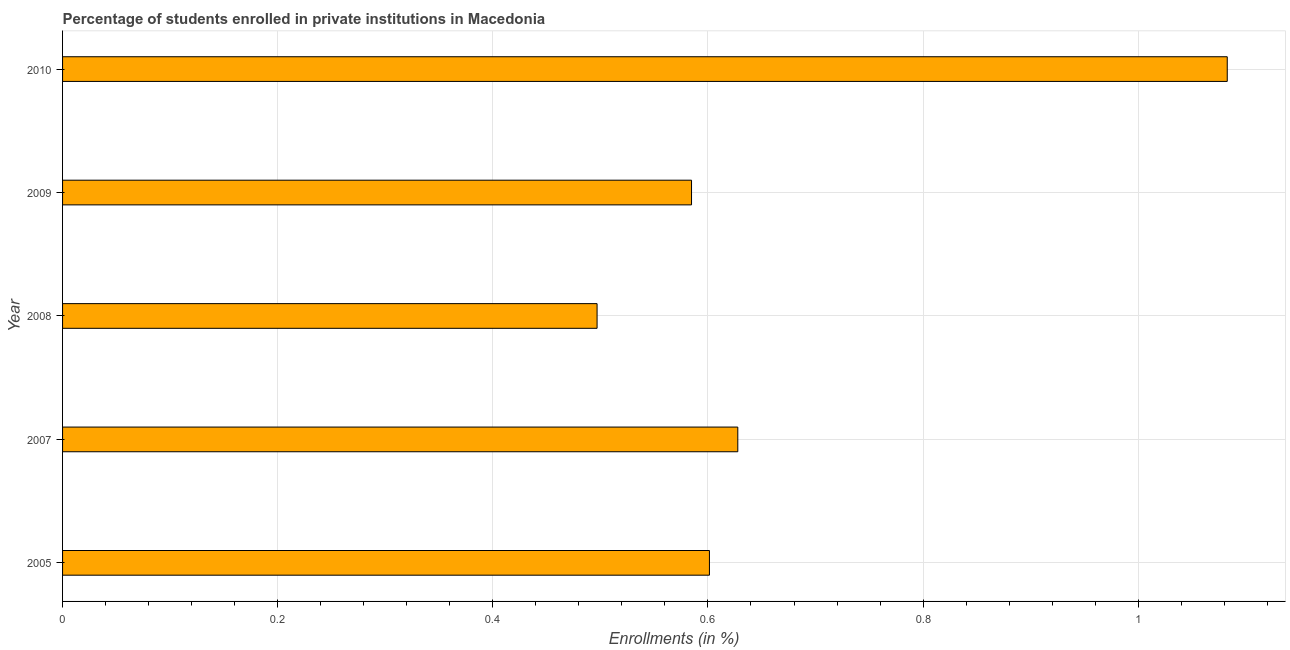Does the graph contain grids?
Your response must be concise. Yes. What is the title of the graph?
Offer a very short reply. Percentage of students enrolled in private institutions in Macedonia. What is the label or title of the X-axis?
Your response must be concise. Enrollments (in %). What is the enrollments in private institutions in 2007?
Give a very brief answer. 0.63. Across all years, what is the maximum enrollments in private institutions?
Keep it short and to the point. 1.08. Across all years, what is the minimum enrollments in private institutions?
Provide a succinct answer. 0.5. In which year was the enrollments in private institutions minimum?
Provide a succinct answer. 2008. What is the sum of the enrollments in private institutions?
Make the answer very short. 3.39. What is the difference between the enrollments in private institutions in 2008 and 2010?
Make the answer very short. -0.59. What is the average enrollments in private institutions per year?
Make the answer very short. 0.68. What is the median enrollments in private institutions?
Your response must be concise. 0.6. In how many years, is the enrollments in private institutions greater than 0.96 %?
Offer a terse response. 1. Do a majority of the years between 2008 and 2007 (inclusive) have enrollments in private institutions greater than 0.16 %?
Provide a succinct answer. No. What is the ratio of the enrollments in private institutions in 2005 to that in 2007?
Provide a short and direct response. 0.96. Is the enrollments in private institutions in 2007 less than that in 2009?
Your answer should be compact. No. What is the difference between the highest and the second highest enrollments in private institutions?
Provide a succinct answer. 0.46. What is the difference between the highest and the lowest enrollments in private institutions?
Provide a short and direct response. 0.59. How many years are there in the graph?
Your answer should be compact. 5. What is the Enrollments (in %) in 2005?
Make the answer very short. 0.6. What is the Enrollments (in %) of 2007?
Your response must be concise. 0.63. What is the Enrollments (in %) in 2008?
Make the answer very short. 0.5. What is the Enrollments (in %) in 2009?
Offer a very short reply. 0.58. What is the Enrollments (in %) in 2010?
Offer a very short reply. 1.08. What is the difference between the Enrollments (in %) in 2005 and 2007?
Give a very brief answer. -0.03. What is the difference between the Enrollments (in %) in 2005 and 2008?
Offer a terse response. 0.1. What is the difference between the Enrollments (in %) in 2005 and 2009?
Provide a succinct answer. 0.02. What is the difference between the Enrollments (in %) in 2005 and 2010?
Provide a succinct answer. -0.48. What is the difference between the Enrollments (in %) in 2007 and 2008?
Give a very brief answer. 0.13. What is the difference between the Enrollments (in %) in 2007 and 2009?
Offer a terse response. 0.04. What is the difference between the Enrollments (in %) in 2007 and 2010?
Keep it short and to the point. -0.46. What is the difference between the Enrollments (in %) in 2008 and 2009?
Your answer should be compact. -0.09. What is the difference between the Enrollments (in %) in 2008 and 2010?
Offer a terse response. -0.59. What is the difference between the Enrollments (in %) in 2009 and 2010?
Provide a succinct answer. -0.5. What is the ratio of the Enrollments (in %) in 2005 to that in 2007?
Keep it short and to the point. 0.96. What is the ratio of the Enrollments (in %) in 2005 to that in 2008?
Your response must be concise. 1.21. What is the ratio of the Enrollments (in %) in 2005 to that in 2009?
Make the answer very short. 1.03. What is the ratio of the Enrollments (in %) in 2005 to that in 2010?
Give a very brief answer. 0.56. What is the ratio of the Enrollments (in %) in 2007 to that in 2008?
Keep it short and to the point. 1.26. What is the ratio of the Enrollments (in %) in 2007 to that in 2009?
Make the answer very short. 1.07. What is the ratio of the Enrollments (in %) in 2007 to that in 2010?
Provide a short and direct response. 0.58. What is the ratio of the Enrollments (in %) in 2008 to that in 2009?
Your response must be concise. 0.85. What is the ratio of the Enrollments (in %) in 2008 to that in 2010?
Provide a succinct answer. 0.46. What is the ratio of the Enrollments (in %) in 2009 to that in 2010?
Provide a succinct answer. 0.54. 